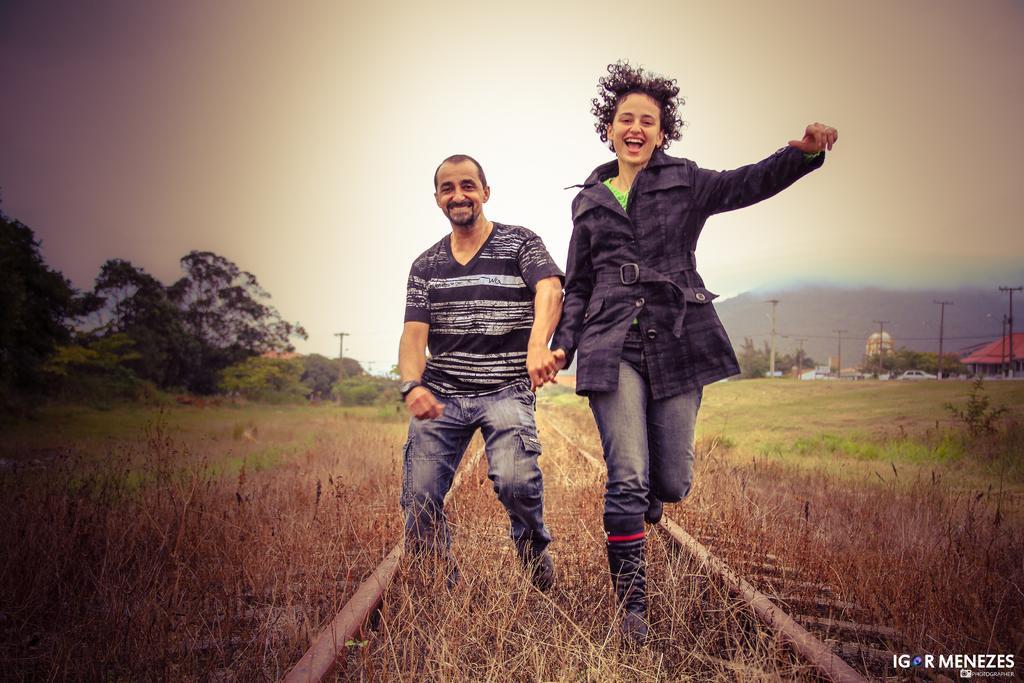Could you give a brief overview of what you see in this image? In this image, we can see people smiling and holding hands. In the background, there are poles along with wires and we can see sheds and vehicles. At the bottom, there is track and grass and at the top, there is sky. 